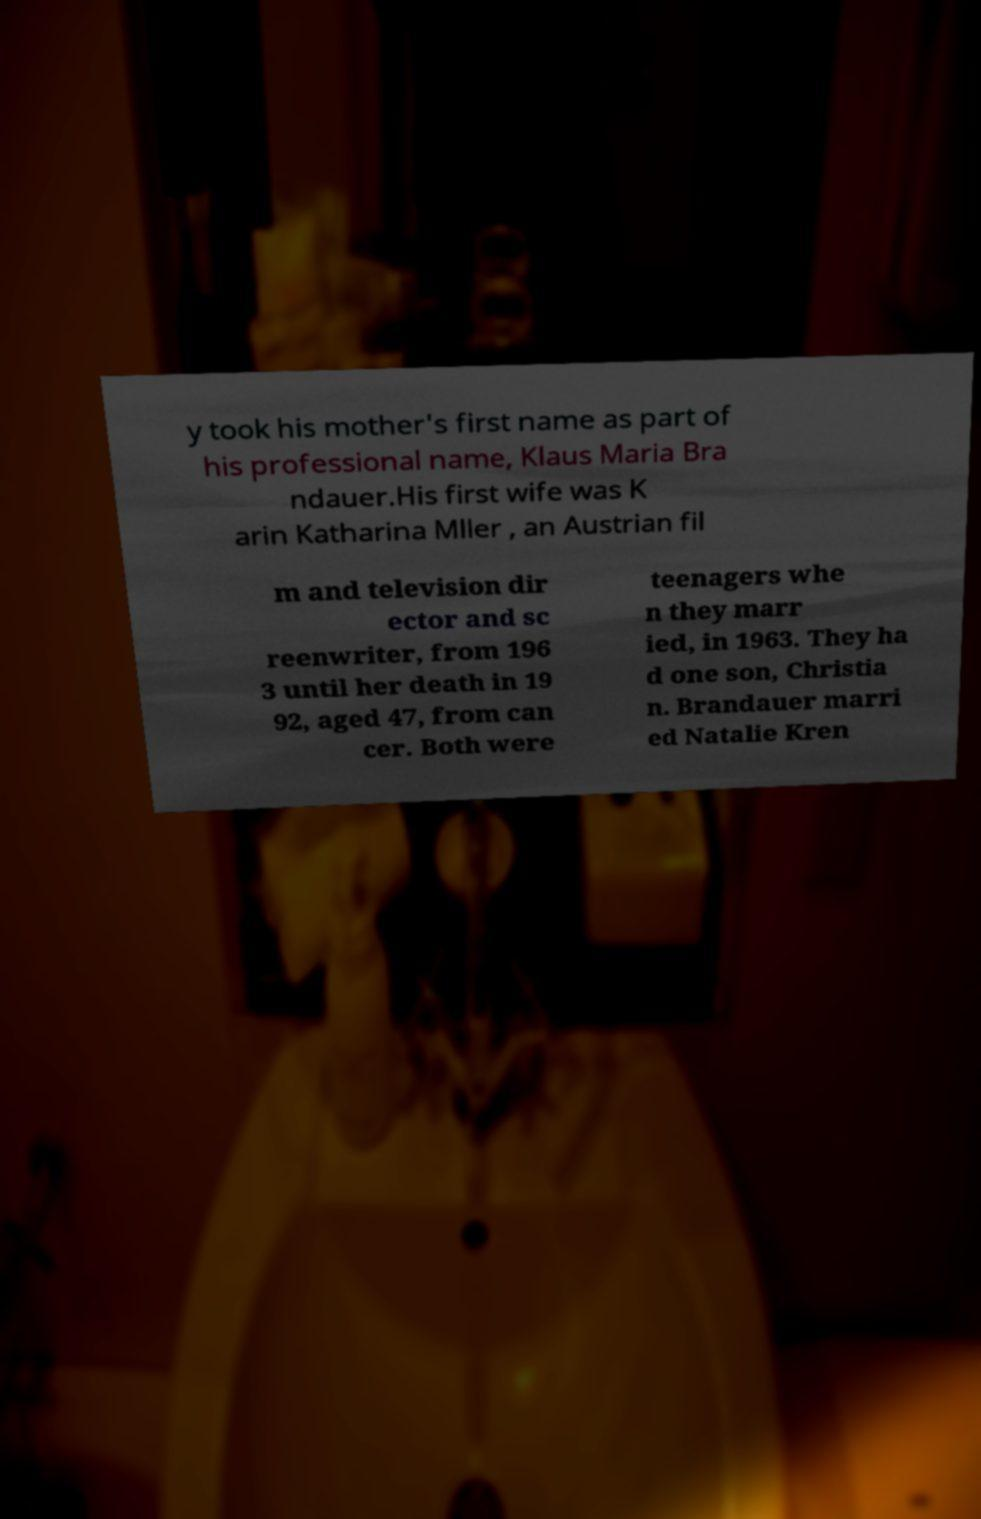Can you accurately transcribe the text from the provided image for me? y took his mother's first name as part of his professional name, Klaus Maria Bra ndauer.His first wife was K arin Katharina Mller , an Austrian fil m and television dir ector and sc reenwriter, from 196 3 until her death in 19 92, aged 47, from can cer. Both were teenagers whe n they marr ied, in 1963. They ha d one son, Christia n. Brandauer marri ed Natalie Kren 